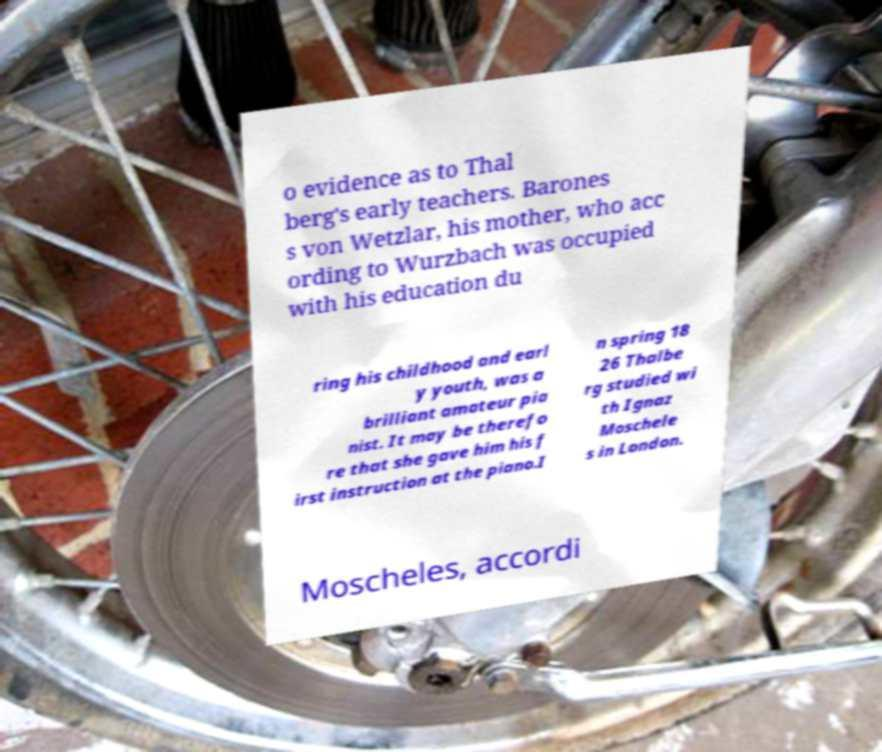Please identify and transcribe the text found in this image. o evidence as to Thal berg's early teachers. Barones s von Wetzlar, his mother, who acc ording to Wurzbach was occupied with his education du ring his childhood and earl y youth, was a brilliant amateur pia nist. It may be therefo re that she gave him his f irst instruction at the piano.I n spring 18 26 Thalbe rg studied wi th Ignaz Moschele s in London. Moscheles, accordi 